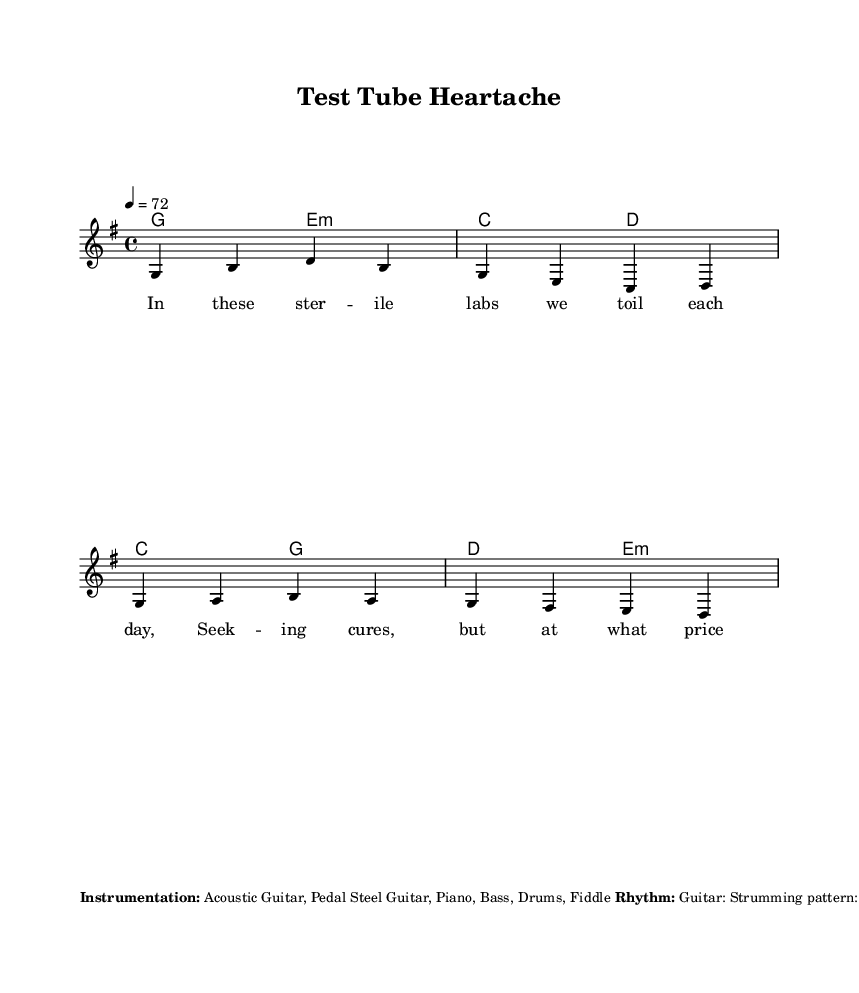What is the key signature of this music? The key signature indicates which notes are sharp or flat in the piece. Looking at the score, the notes suggest it uses one sharp on F, which is representative of the key signature of G major.
Answer: G major What is the time signature of this music? The time signature shows how many beats are in each measure and what note gets the beat. In this score, the time signature is written as 4/4, indicating there are four beats per measure, with the quarter note receiving one beat.
Answer: 4/4 What is the tempo marking of this piece? The tempo marking gives the speed of the music and is indicated at the beginning of the score. Here, it is marked as equals 72 beats per minute, telling us the pace at which the piece should be played.
Answer: 72 How many verses are present in the song structure? To determine the number of verses, we check the structure outlined in the score. The provided lyrics include a verse section that is repeated before the chorus, suggesting there is one complete verse preceding the chorus.
Answer: One What instrumentation is used in this composition? The instrumentation is listed in the markup section at the end of the score. It includes Acoustic Guitar, Pedal Steel Guitar, Piano, Bass, Drums, and Fiddle, which collectively contribute to the country music style.
Answer: Acoustic Guitar, Pedal Steel Guitar, Piano, Bass, Drums, Fiddle What is the main theme explored in the lyrics of this ballad? The main theme is derived from the lyrics presented in the verse and chorus. The focus appears to be on ethical dilemmas in medical research, emphasizing emotional struggles tied to scientific progress as indicated by phrases such as "Test tube heartache."
Answer: Ethical dilemmas in medical research 